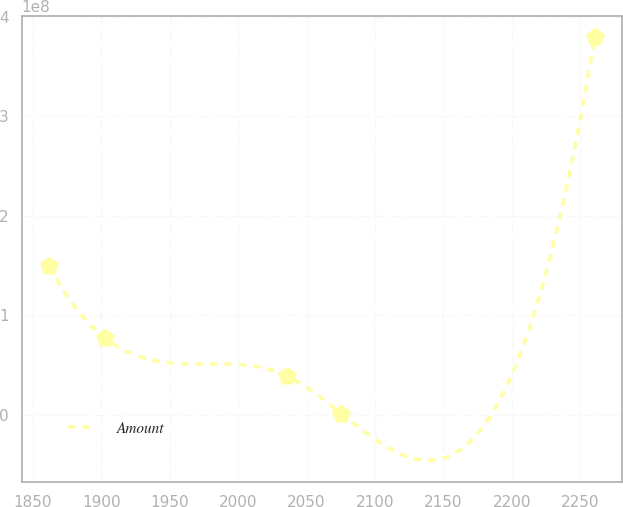<chart> <loc_0><loc_0><loc_500><loc_500><line_chart><ecel><fcel>Amount<nl><fcel>1861.96<fcel>1.49204e+08<nl><fcel>1903.16<fcel>7.66147e+07<nl><fcel>2035.56<fcel>3.87666e+07<nl><fcel>2075.41<fcel>918533<nl><fcel>2260.44<fcel>3.794e+08<nl></chart> 